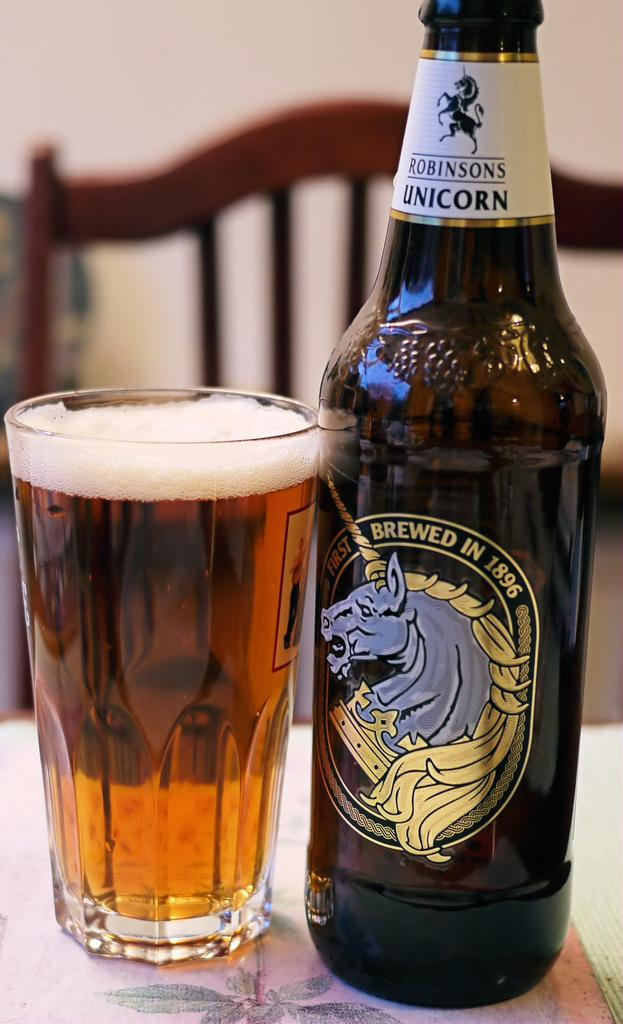<image>
Render a clear and concise summary of the photo. A glass full of a beverage and a bottle of Robinson's Unicorn 